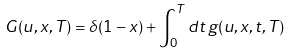<formula> <loc_0><loc_0><loc_500><loc_500>G ( u , x , T ) = \delta ( 1 - x ) + \int _ { 0 } ^ { T } d t \, g ( u , x , t , T )</formula> 